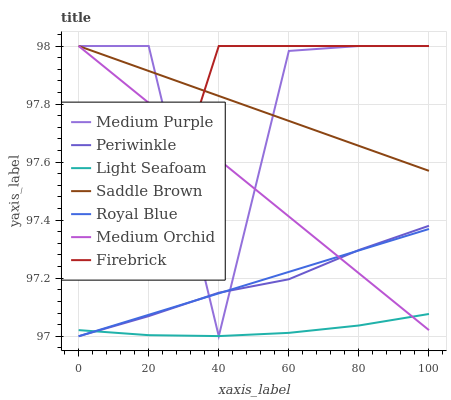Does Medium Orchid have the minimum area under the curve?
Answer yes or no. No. Does Medium Orchid have the maximum area under the curve?
Answer yes or no. No. Is Medium Purple the smoothest?
Answer yes or no. No. Is Medium Orchid the roughest?
Answer yes or no. No. Does Medium Orchid have the lowest value?
Answer yes or no. No. Does Royal Blue have the highest value?
Answer yes or no. No. Is Periwinkle less than Firebrick?
Answer yes or no. Yes. Is Firebrick greater than Royal Blue?
Answer yes or no. Yes. Does Periwinkle intersect Firebrick?
Answer yes or no. No. 